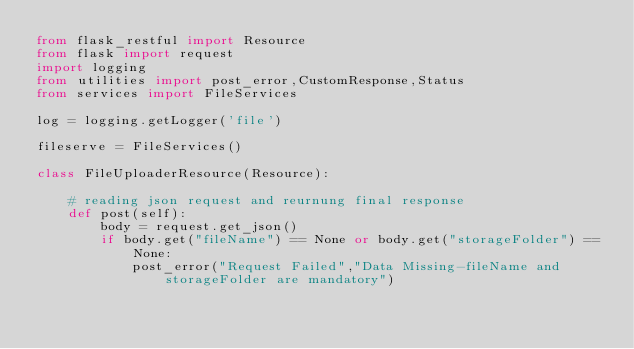<code> <loc_0><loc_0><loc_500><loc_500><_Python_>from flask_restful import Resource
from flask import request
import logging
from utilities import post_error,CustomResponse,Status
from services import FileServices

log = logging.getLogger('file')

fileserve = FileServices()

class FileUploaderResource(Resource):

    # reading json request and reurnung final response
    def post(self):
        body = request.get_json()
        if body.get("fileName") == None or body.get("storageFolder") == None:
            post_error("Request Failed","Data Missing-fileName and storageFolder are mandatory")</code> 